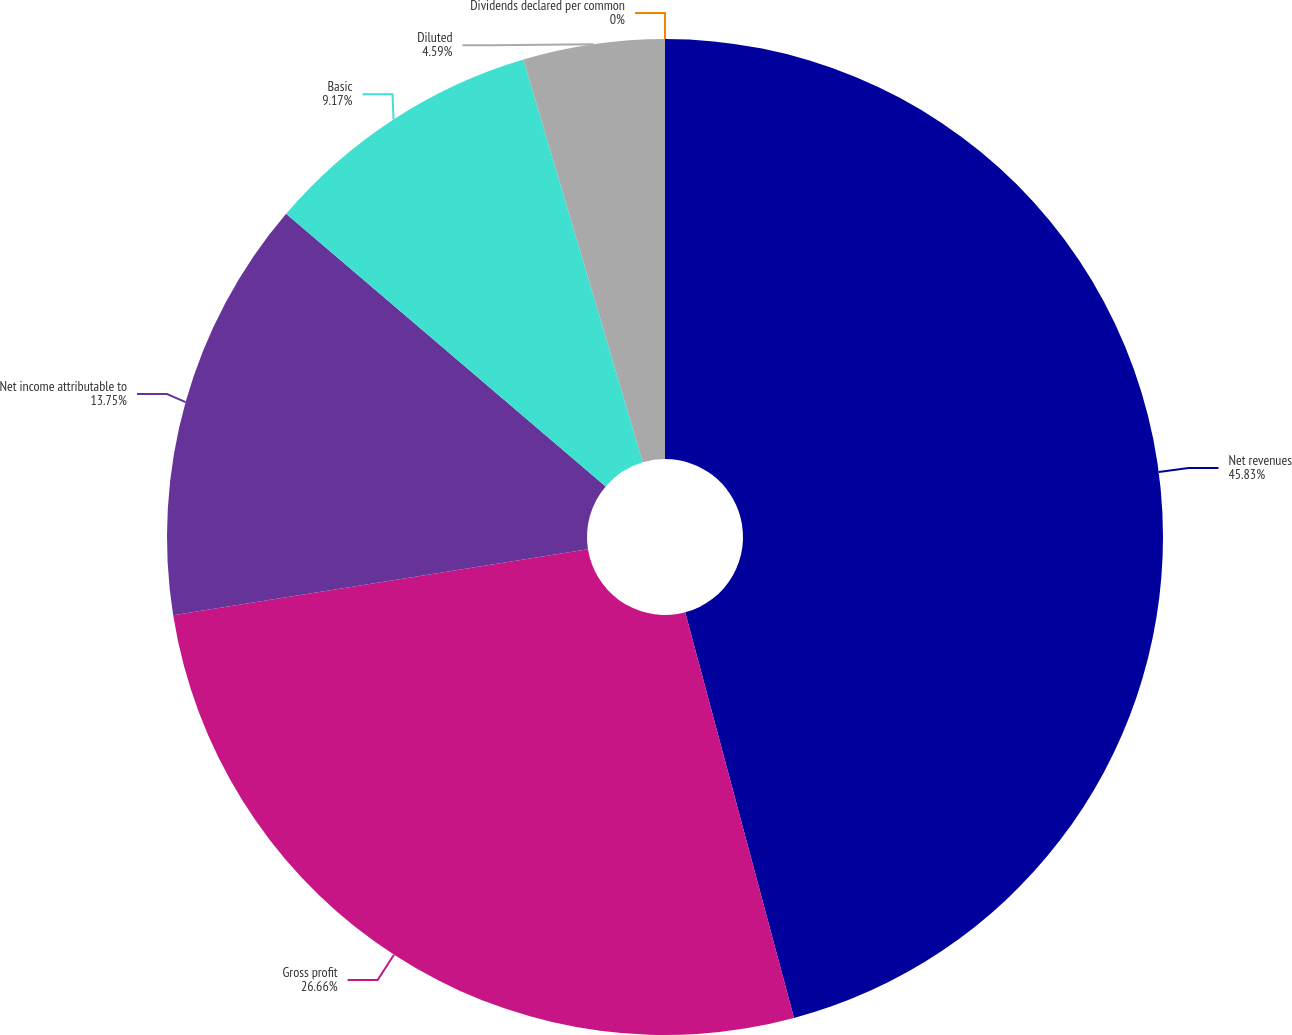<chart> <loc_0><loc_0><loc_500><loc_500><pie_chart><fcel>Net revenues<fcel>Gross profit<fcel>Net income attributable to<fcel>Basic<fcel>Diluted<fcel>Dividends declared per common<nl><fcel>45.83%<fcel>26.66%<fcel>13.75%<fcel>9.17%<fcel>4.59%<fcel>0.0%<nl></chart> 